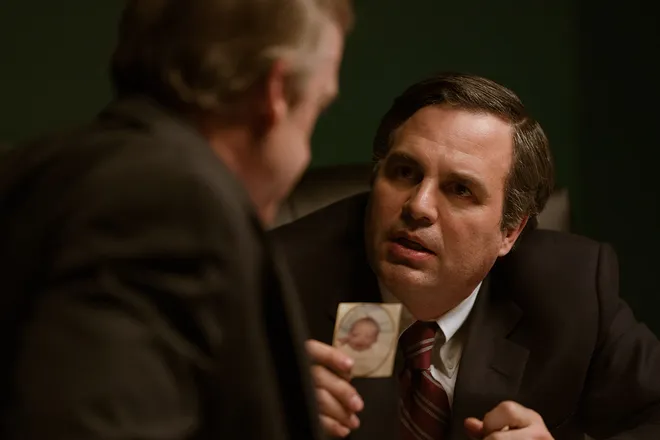If this scene were in a completely different genre, such as a comedy, how would the context change? In a comedic context, this scene could be drastically different. The serious expressions and tension might be replaced with exaggerated gestures and witty dialogue. The photograph could be of something humorous, perhaps a mischievous pet or an embarrassing moment caught on camera. Rob Bilott might be making an over-the-top, humorous plea, trying to convince the other man of something trivial or absurd. The lighting might be brighter, and the characters' interactions would be more animated and playful, turning the tension into humor. Imagine the photograph holds a dark secret that could change the world. How does this impact the scene and the characters involved? If the photograph holds a dark secret capable of changing the world, the scene gains a colossal weight. Rob Bilott’s plea would now be seen as a critical moment in potentially altering history. The gravity of what the photograph represents could put immense pressure on both characters. The other man, holding the photograph, might be grappling with the morality of revealing this secret. The atmosphere would become more charged with ethical dilemmas and the stakes would escalate dramatically, portraying this scene as a pivotal moment where the future hangs in the balance. 